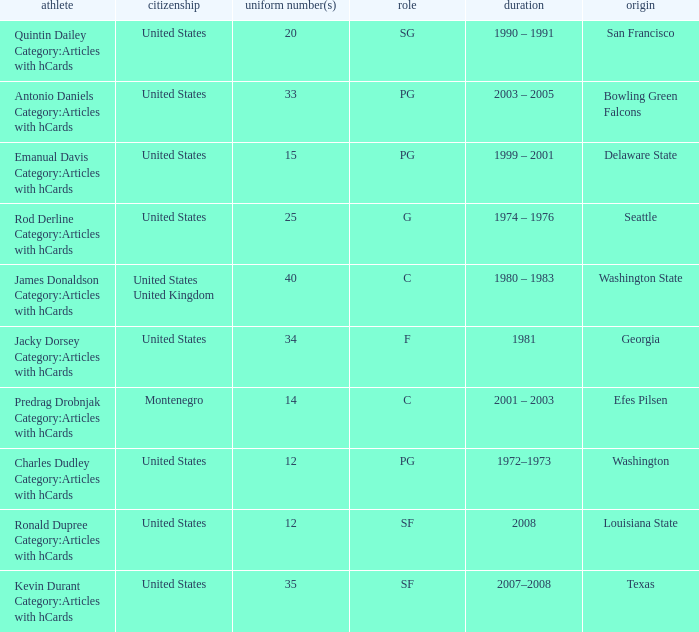What years did the united states player with a jersey number 25 who attended delaware state play? 1999 – 2001. 